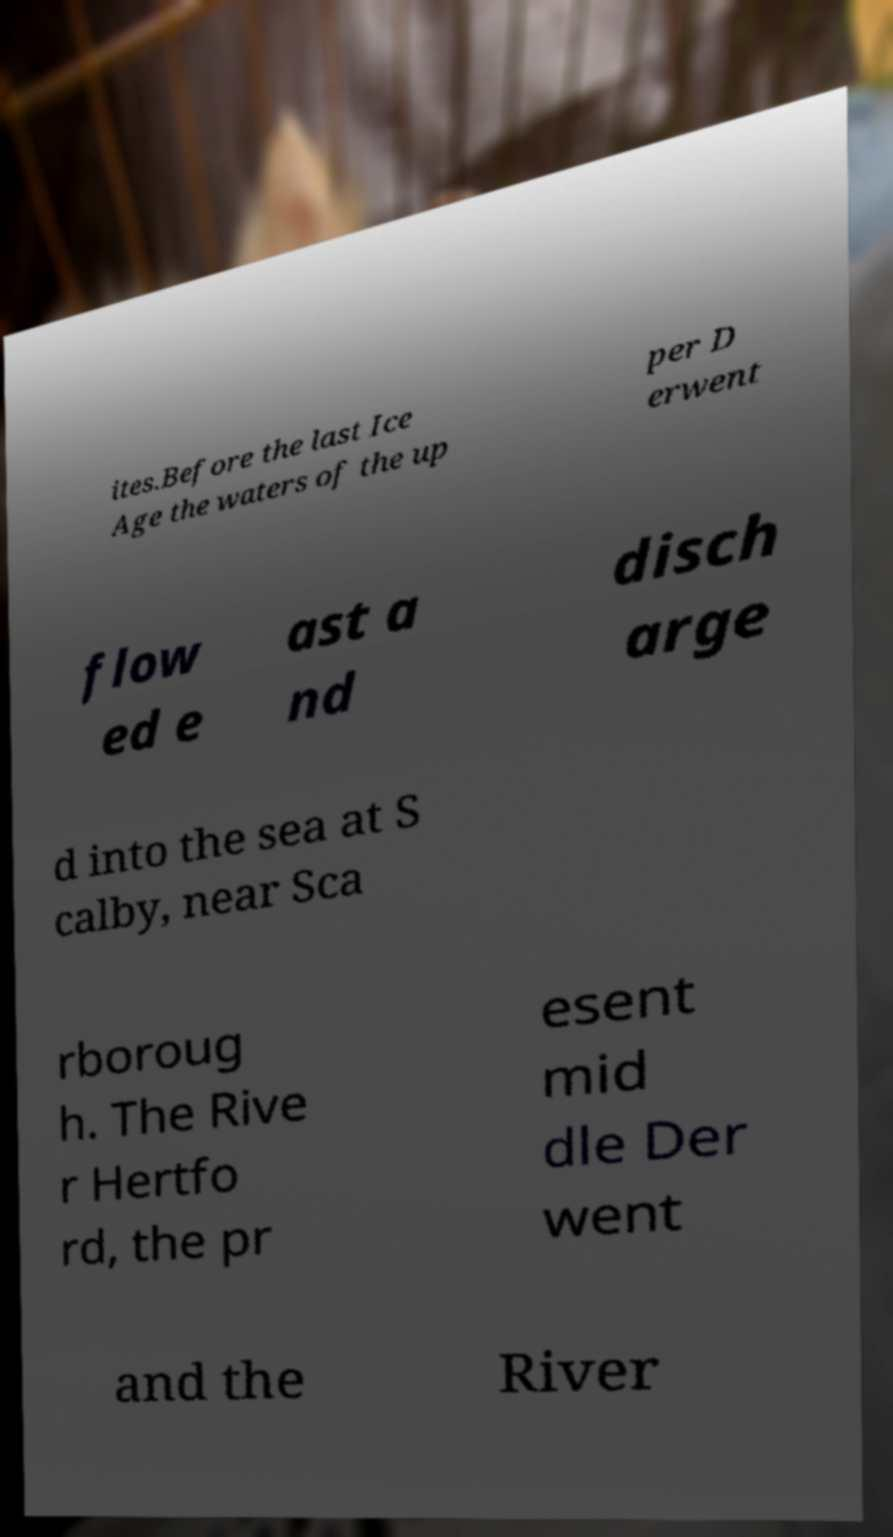Please identify and transcribe the text found in this image. ites.Before the last Ice Age the waters of the up per D erwent flow ed e ast a nd disch arge d into the sea at S calby, near Sca rboroug h. The Rive r Hertfo rd, the pr esent mid dle Der went and the River 